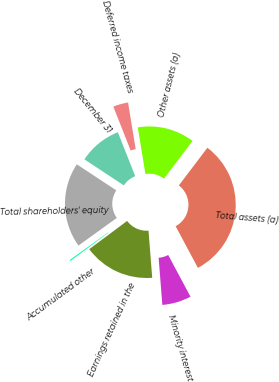Convert chart to OTSL. <chart><loc_0><loc_0><loc_500><loc_500><pie_chart><fcel>December 31<fcel>Deferred income taxes<fcel>Other assets (a)<fcel>Total assets (a)<fcel>Minority interest<fcel>Earnings retained in the<fcel>Accumulated other<fcel>Total shareholders' equity<nl><fcel>9.73%<fcel>3.41%<fcel>12.9%<fcel>31.86%<fcel>6.57%<fcel>16.06%<fcel>0.25%<fcel>19.22%<nl></chart> 